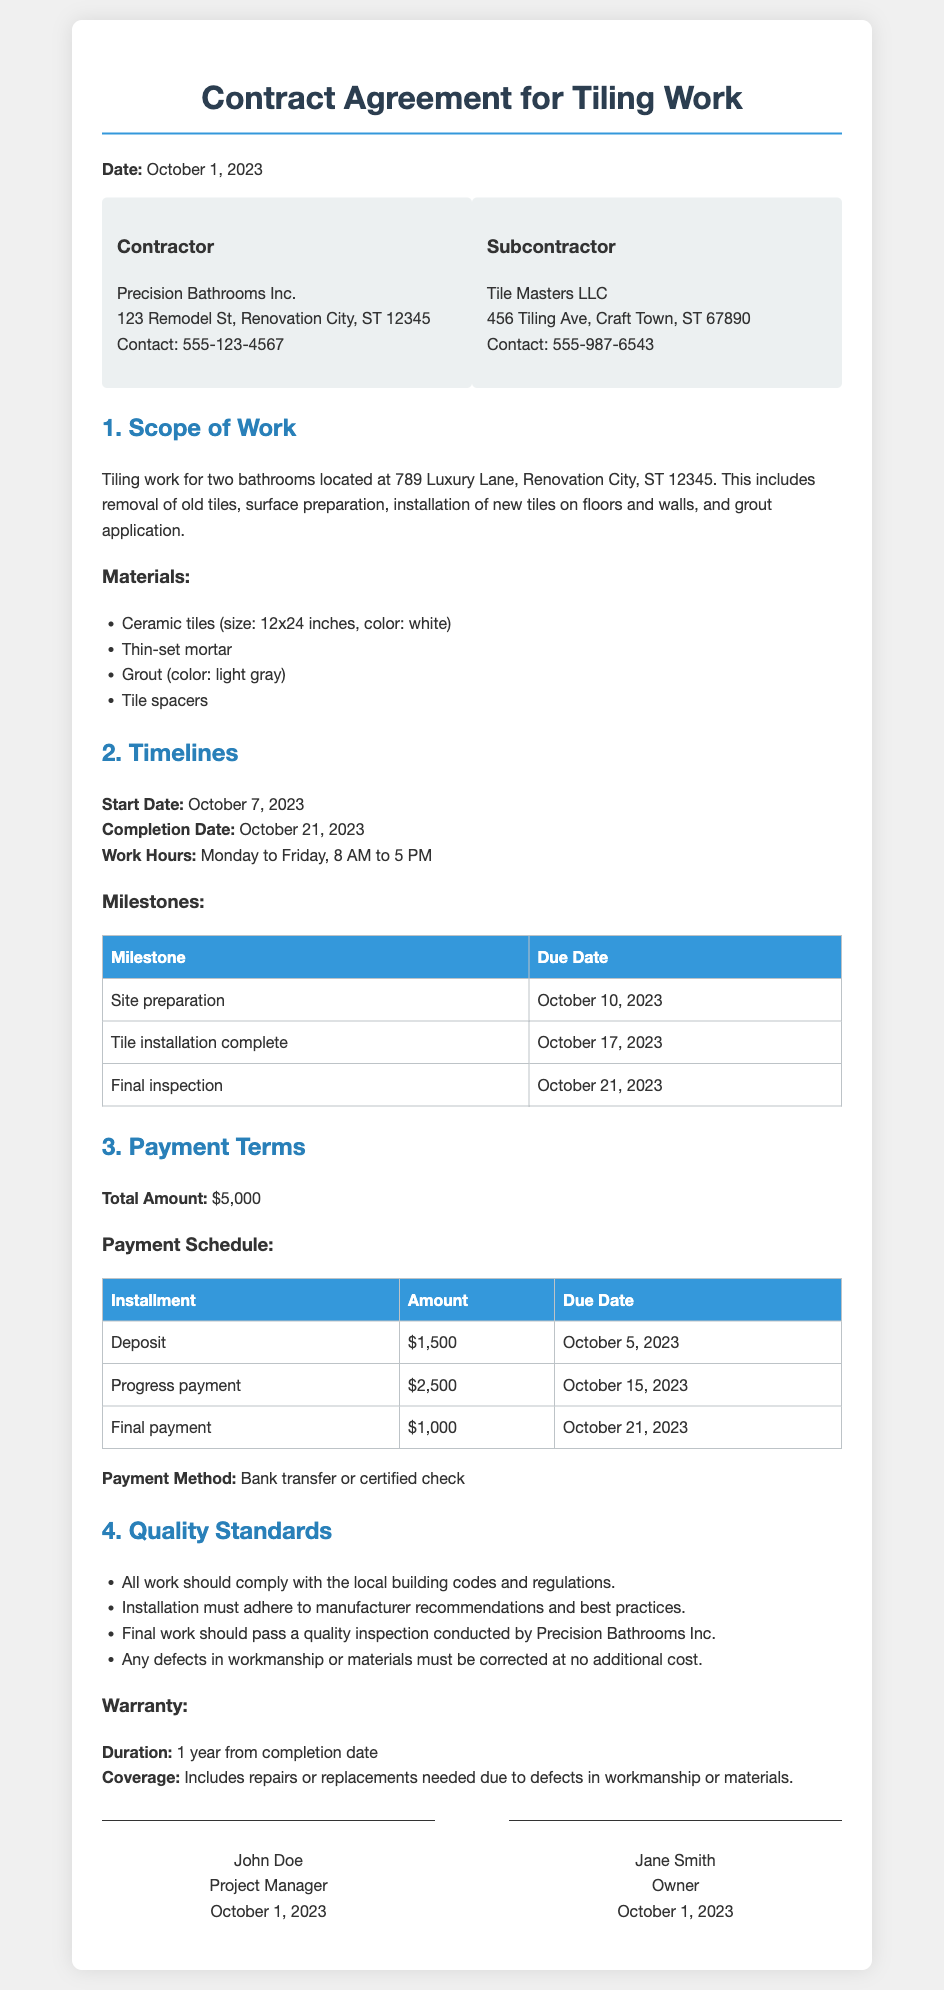What is the total contract amount? The total contract amount for the tiling work specified in the document is $5,000.
Answer: $5,000 What is the start date of the project? The contract specifies that the start date for the tiling work is October 7, 2023.
Answer: October 7, 2023 Who is the subcontractor? The document identifies the subcontractor as Tile Masters LLC.
Answer: Tile Masters LLC What is the final payment amount and due date? The final payment amount is $1,000, and it is due on October 21, 2023.
Answer: $1,000, October 21, 2023 What quality standard includes defect coverage? The warranty section mentions coverage includes repairs or replacements needed due to defects in workmanship or materials.
Answer: Defects in workmanship or materials How many bathrooms are included in the scope of work? The document states that the tiling work is for two bathrooms.
Answer: Two bathrooms When is the site preparation milestone due? According to the milestones table, the site preparation is due on October 10, 2023.
Answer: October 10, 2023 What materials are specified for the tiling work? The document lists ceramic tiles (size: 12x24 inches, color: white), thin-set mortar, grout (color: light gray), and tile spacers as materials.
Answer: Ceramic tiles, thin-set mortar, grout, tile spacers What must all work comply with according to quality standards? The quality standards state that all work should comply with the local building codes and regulations.
Answer: Local building codes and regulations 